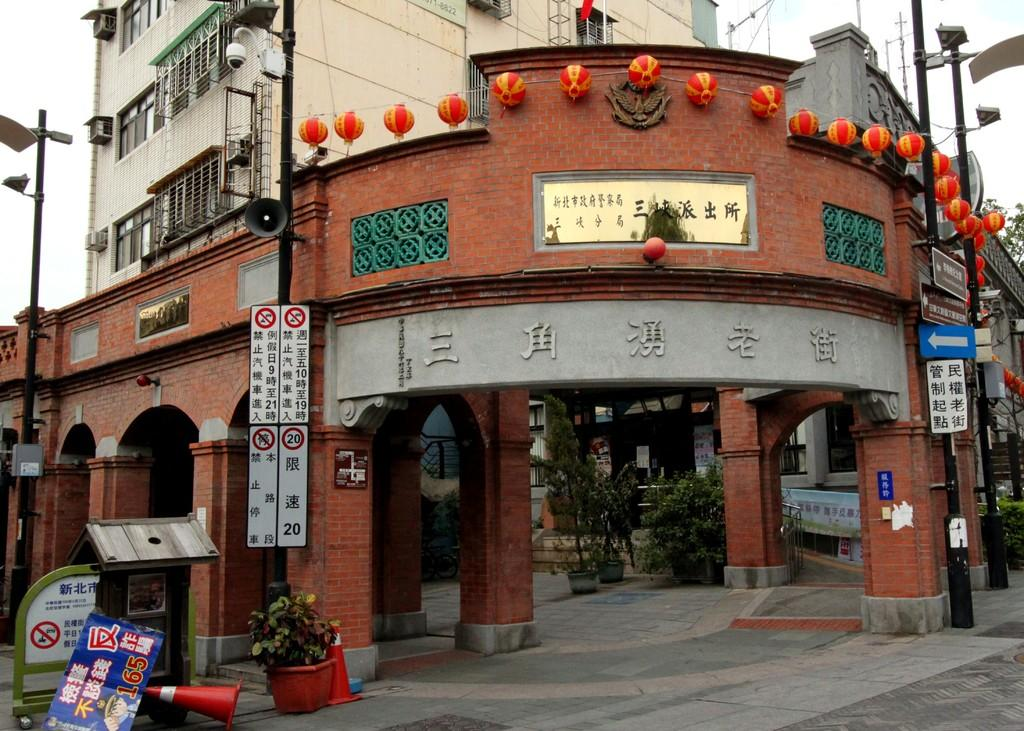What type of structures can be seen in the image? There are buildings in the image. What other objects are present in the image besides buildings? Decorative items, electric poles, boards with text, plants, safety cones, and a road are visible in the image. Can you describe the decorative items in the image? Unfortunately, the specific decorative items cannot be identified from the provided facts. What might be the purpose of the boards with text in the image? The boards with text might be used for signage or advertising. What type of vegetation is present in the image? Plants are present in the image. What type of pot is being used to hold the yarn in the image? There is no pot or yarn present in the image. What type of ornament is hanging from the electric poles in the image? The provided facts do not mention any ornaments hanging from the electric poles. 